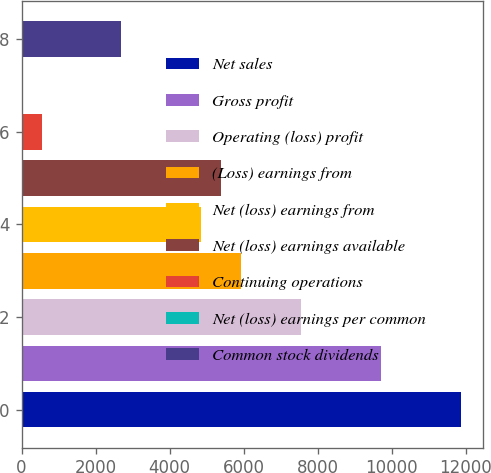Convert chart. <chart><loc_0><loc_0><loc_500><loc_500><bar_chart><fcel>Net sales<fcel>Gross profit<fcel>Operating (loss) profit<fcel>(Loss) earnings from<fcel>Net (loss) earnings from<fcel>Net (loss) earnings available<fcel>Continuing operations<fcel>Net (loss) earnings per common<fcel>Common stock dividends<nl><fcel>11877<fcel>9717.84<fcel>7558.64<fcel>5939.24<fcel>4859.64<fcel>5399.44<fcel>541.24<fcel>1.44<fcel>2700.44<nl></chart> 